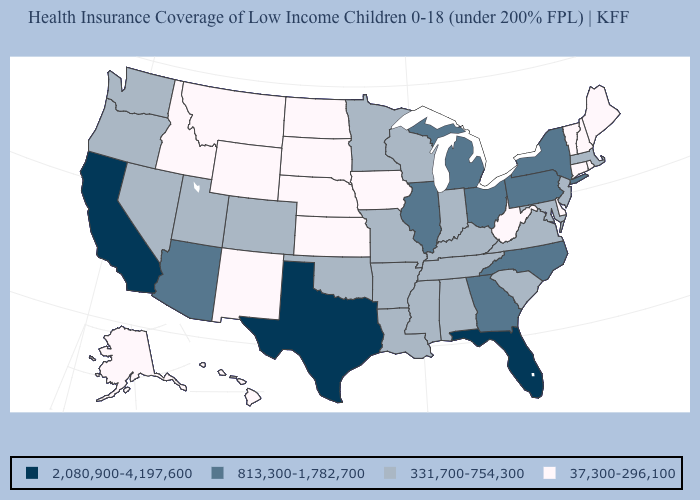What is the lowest value in the Northeast?
Concise answer only. 37,300-296,100. Name the states that have a value in the range 331,700-754,300?
Short answer required. Alabama, Arkansas, Colorado, Indiana, Kentucky, Louisiana, Maryland, Massachusetts, Minnesota, Mississippi, Missouri, Nevada, New Jersey, Oklahoma, Oregon, South Carolina, Tennessee, Utah, Virginia, Washington, Wisconsin. What is the value of New Jersey?
Write a very short answer. 331,700-754,300. Name the states that have a value in the range 331,700-754,300?
Be succinct. Alabama, Arkansas, Colorado, Indiana, Kentucky, Louisiana, Maryland, Massachusetts, Minnesota, Mississippi, Missouri, Nevada, New Jersey, Oklahoma, Oregon, South Carolina, Tennessee, Utah, Virginia, Washington, Wisconsin. Does Kentucky have the highest value in the South?
Quick response, please. No. What is the value of Kentucky?
Be succinct. 331,700-754,300. What is the highest value in the USA?
Write a very short answer. 2,080,900-4,197,600. Name the states that have a value in the range 37,300-296,100?
Keep it brief. Alaska, Connecticut, Delaware, Hawaii, Idaho, Iowa, Kansas, Maine, Montana, Nebraska, New Hampshire, New Mexico, North Dakota, Rhode Island, South Dakota, Vermont, West Virginia, Wyoming. What is the lowest value in states that border Nebraska?
Answer briefly. 37,300-296,100. What is the value of Nebraska?
Give a very brief answer. 37,300-296,100. What is the highest value in states that border Minnesota?
Short answer required. 331,700-754,300. Does Illinois have the lowest value in the MidWest?
Keep it brief. No. Name the states that have a value in the range 813,300-1,782,700?
Quick response, please. Arizona, Georgia, Illinois, Michigan, New York, North Carolina, Ohio, Pennsylvania. Among the states that border New Jersey , which have the lowest value?
Short answer required. Delaware. 